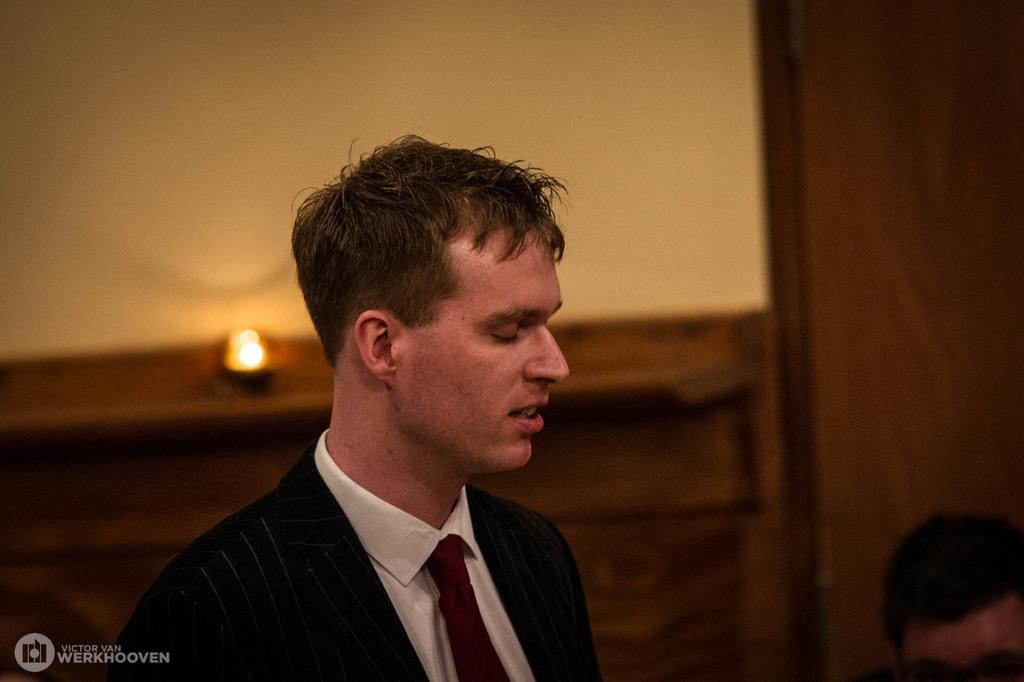What is the main subject of the image? There is a person in the image. What is the person wearing? The person is wearing a coat. What is the person's facial expression or state? The person's eyes are closed. What can be seen in the image besides the person? There is light visible in the image. What type of tank is visible in the image? There is no tank present in the image. What kind of guitar is the person playing in the image? There is no guitar present in the image, and the person's eyes are closed, so they are not playing any instrument. 